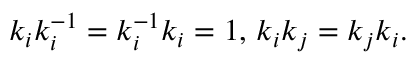Convert formula to latex. <formula><loc_0><loc_0><loc_500><loc_500>k _ { i } k _ { i } ^ { - 1 } = k _ { i } ^ { - 1 } k _ { i } = 1 , \, k _ { i } k _ { j } = k _ { j } k _ { i } .</formula> 